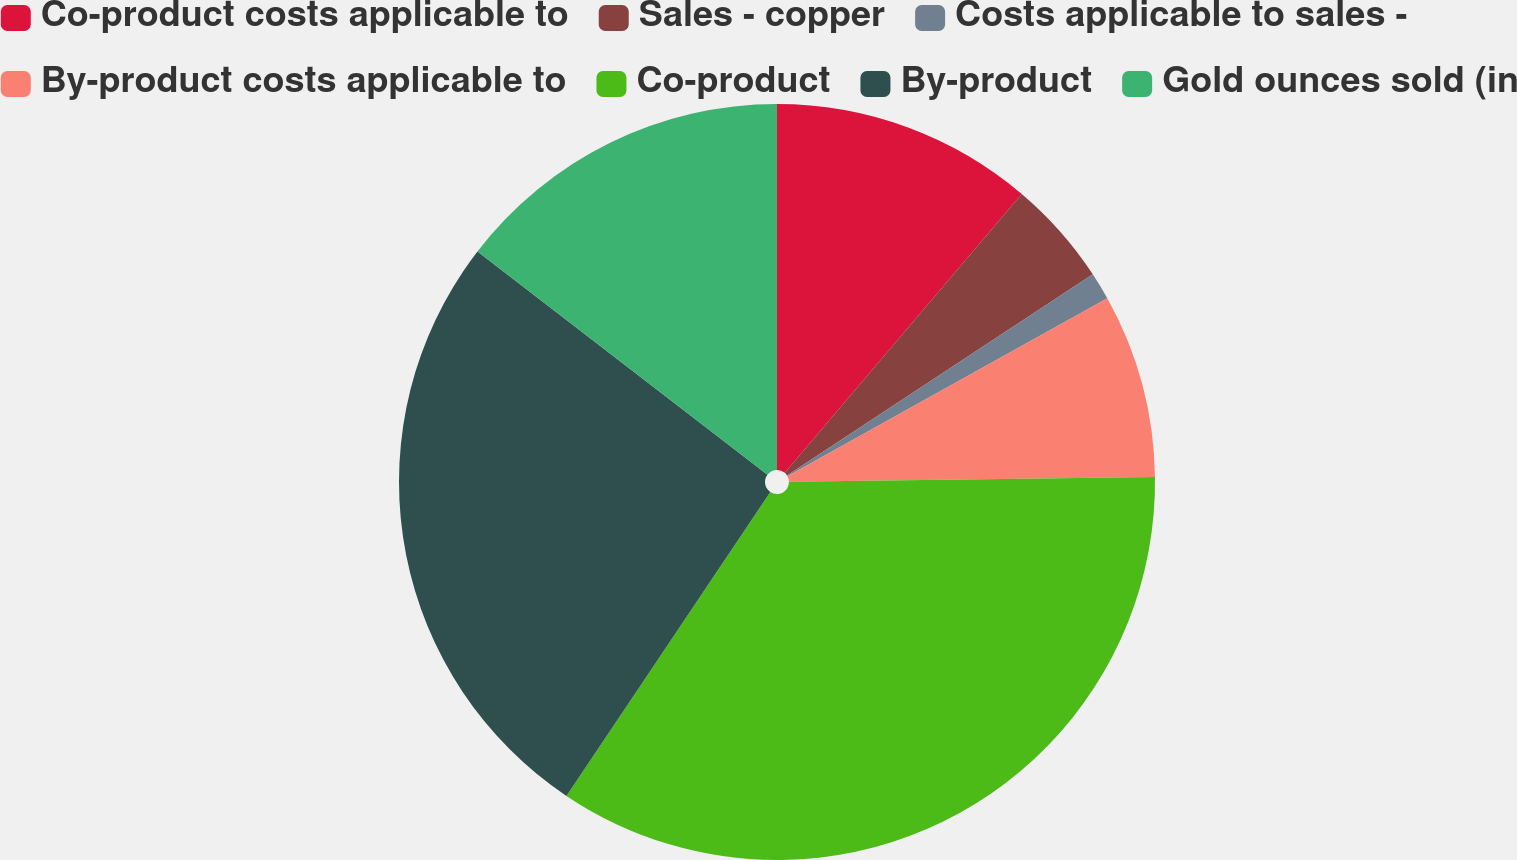Convert chart. <chart><loc_0><loc_0><loc_500><loc_500><pie_chart><fcel>Co-product costs applicable to<fcel>Sales - copper<fcel>Costs applicable to sales -<fcel>By-product costs applicable to<fcel>Co-product<fcel>By-product<fcel>Gold ounces sold (in<nl><fcel>11.21%<fcel>4.53%<fcel>1.18%<fcel>7.87%<fcel>34.62%<fcel>26.04%<fcel>14.56%<nl></chart> 